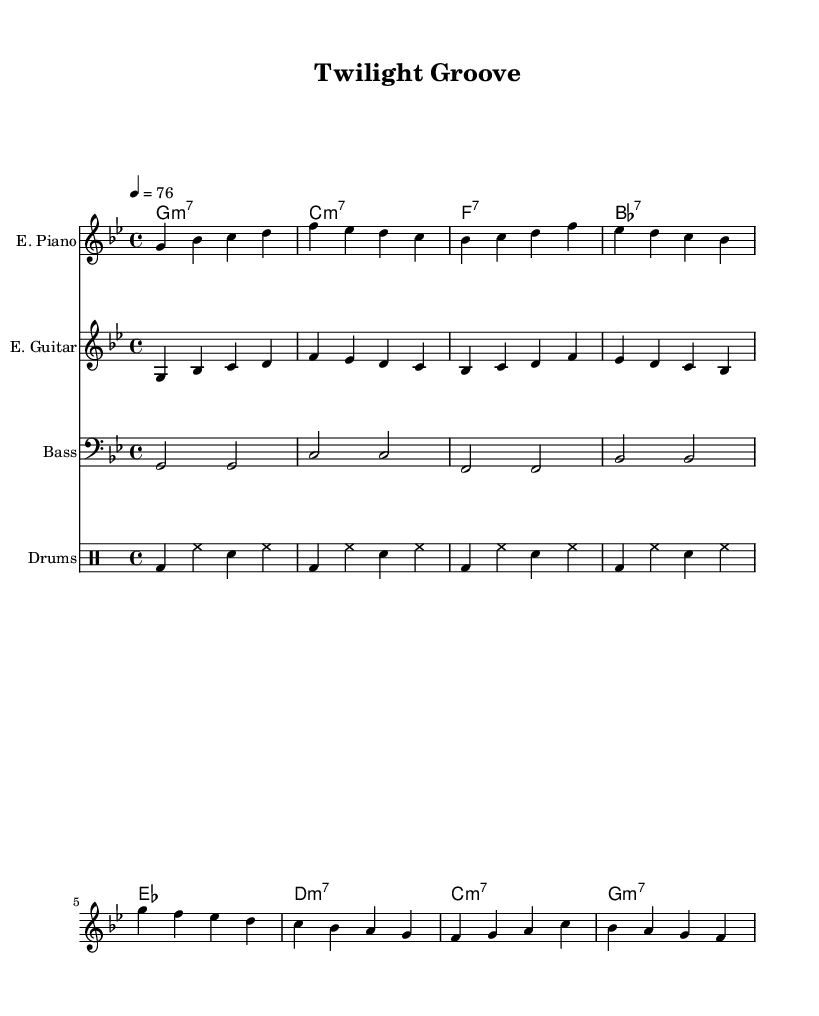What is the key signature of this music? The key signature indicates G minor, which has two flats (B flat and E flat).
Answer: G minor What is the time signature? The time signature is found at the beginning of the score, which indicates four beats per measure.
Answer: 4/4 What is the tempo marking of the piece? The tempo marking is given as a quarter note = 76, which indicates the speed of the music.
Answer: 76 How many instruments are present in the score? There are four distinct instruments represented in the score: electric piano, electric guitar, bass guitar, and drums.
Answer: Four What type of seventh chords are used in the chord progression? The chord progression contains minor seventh chords and dominant seventh chords, which are characteristic elements in funk music.
Answer: Minor seventh, dominant seventh Which instrument plays the main melody? The electric piano primarily carries the main melody throughout the piece, as it contains the main notes written in treble clef.
Answer: Electric piano What is the rhythmic pattern typically used by the drums in this piece? The drumming pattern alternates between bass drum and snare hits, maintaining a consistent groove that supports the funk style.
Answer: Bass drum and snare 